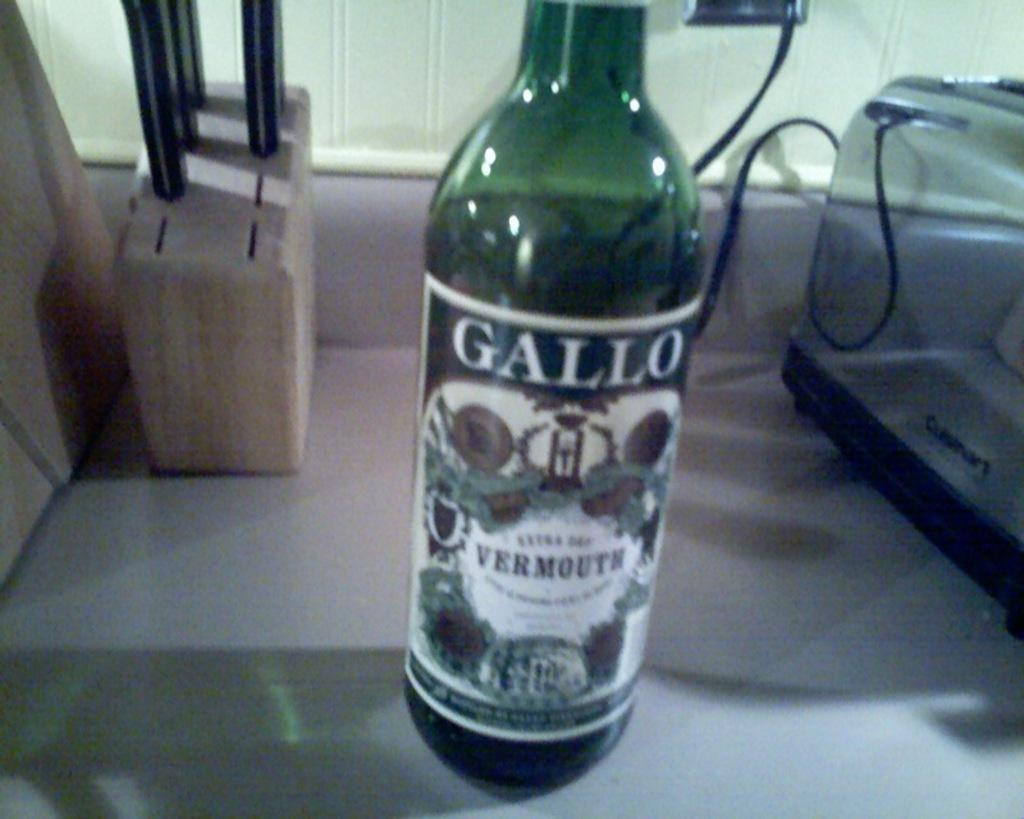<image>
Write a terse but informative summary of the picture. GALLO bottle sits next to the Cuisinart toaster 